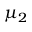<formula> <loc_0><loc_0><loc_500><loc_500>\mu _ { 2 }</formula> 